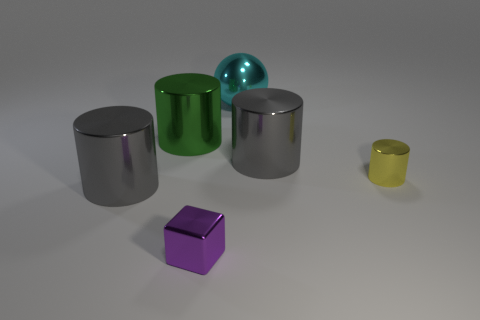Add 2 large gray things. How many objects exist? 8 Subtract all cyan cylinders. Subtract all brown cubes. How many cylinders are left? 4 Subtract all cylinders. How many objects are left? 2 Add 6 large green metal cylinders. How many large green metal cylinders are left? 7 Add 6 large green metallic cylinders. How many large green metallic cylinders exist? 7 Subtract 0 red blocks. How many objects are left? 6 Subtract all tiny cyan metal spheres. Subtract all metal balls. How many objects are left? 5 